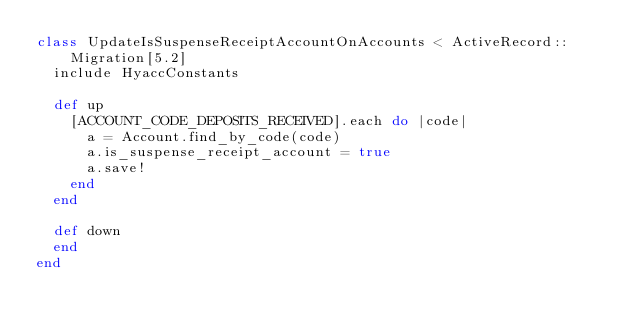Convert code to text. <code><loc_0><loc_0><loc_500><loc_500><_Ruby_>class UpdateIsSuspenseReceiptAccountOnAccounts < ActiveRecord::Migration[5.2]
  include HyaccConstants

  def up
    [ACCOUNT_CODE_DEPOSITS_RECEIVED].each do |code|
      a = Account.find_by_code(code)
      a.is_suspense_receipt_account = true
      a.save!
    end
  end
  
  def down
  end
end
</code> 